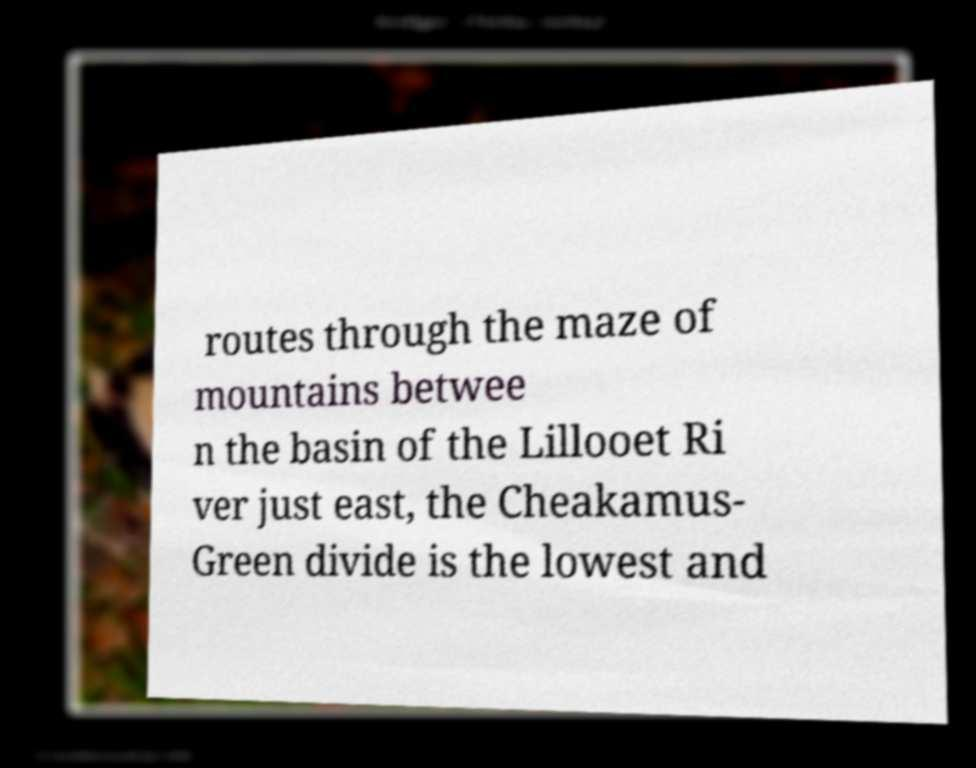There's text embedded in this image that I need extracted. Can you transcribe it verbatim? routes through the maze of mountains betwee n the basin of the Lillooet Ri ver just east, the Cheakamus- Green divide is the lowest and 